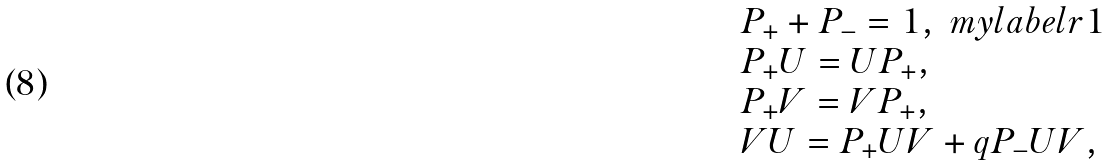Convert formula to latex. <formula><loc_0><loc_0><loc_500><loc_500>\begin{array} { l } P _ { + } + P _ { - } = 1 , \ m y l a b e l { r 1 } \\ P _ { + } U = U P _ { + } , \\ P _ { + } V = V P _ { + } , \\ V U = P _ { + } U V + q P _ { - } U V , \end{array}</formula> 